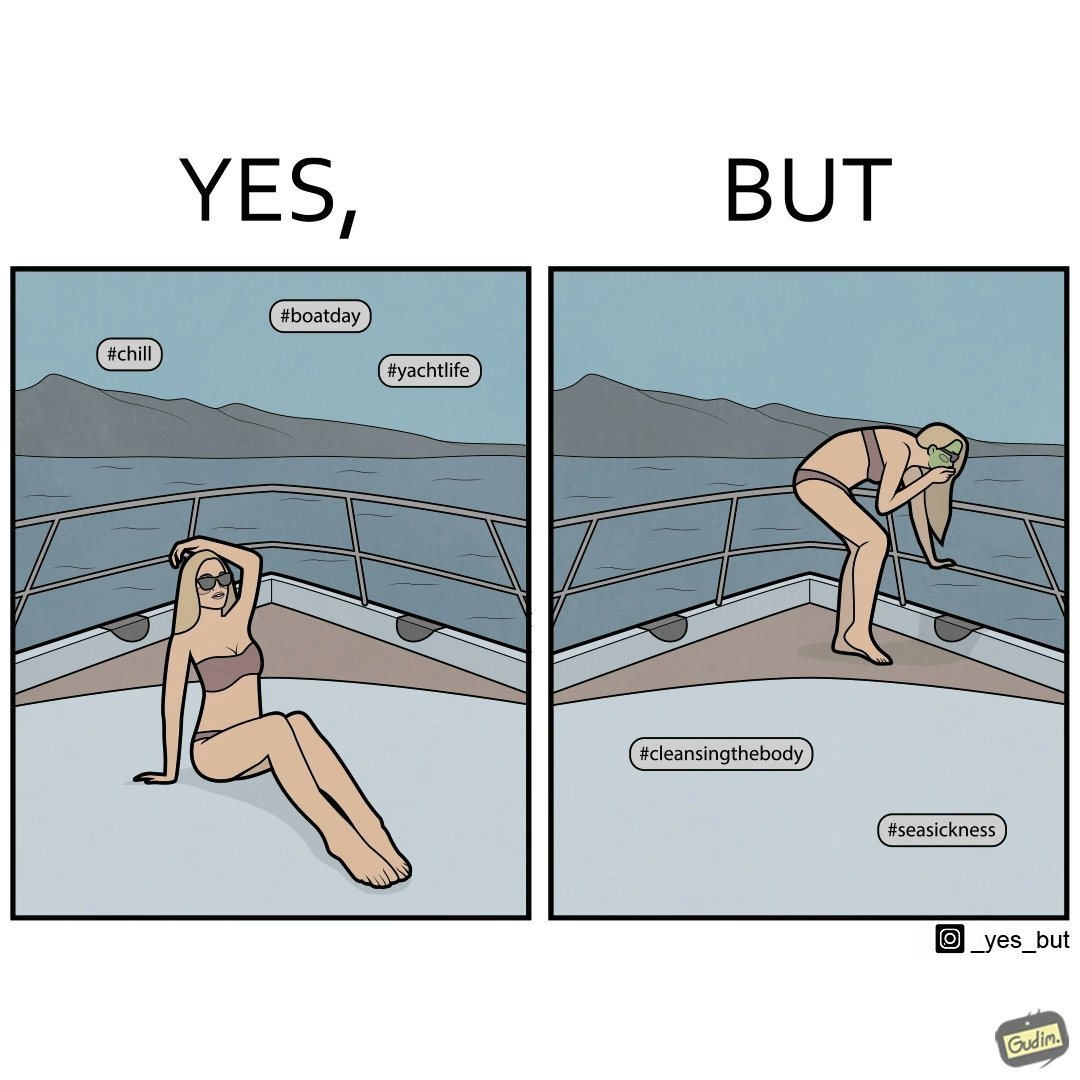Would you classify this image as satirical? Yes, this image is satirical. 